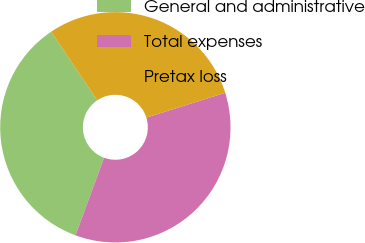<chart> <loc_0><loc_0><loc_500><loc_500><pie_chart><fcel>General and administrative<fcel>Total expenses<fcel>Pretax loss<nl><fcel>34.95%<fcel>35.48%<fcel>29.57%<nl></chart> 